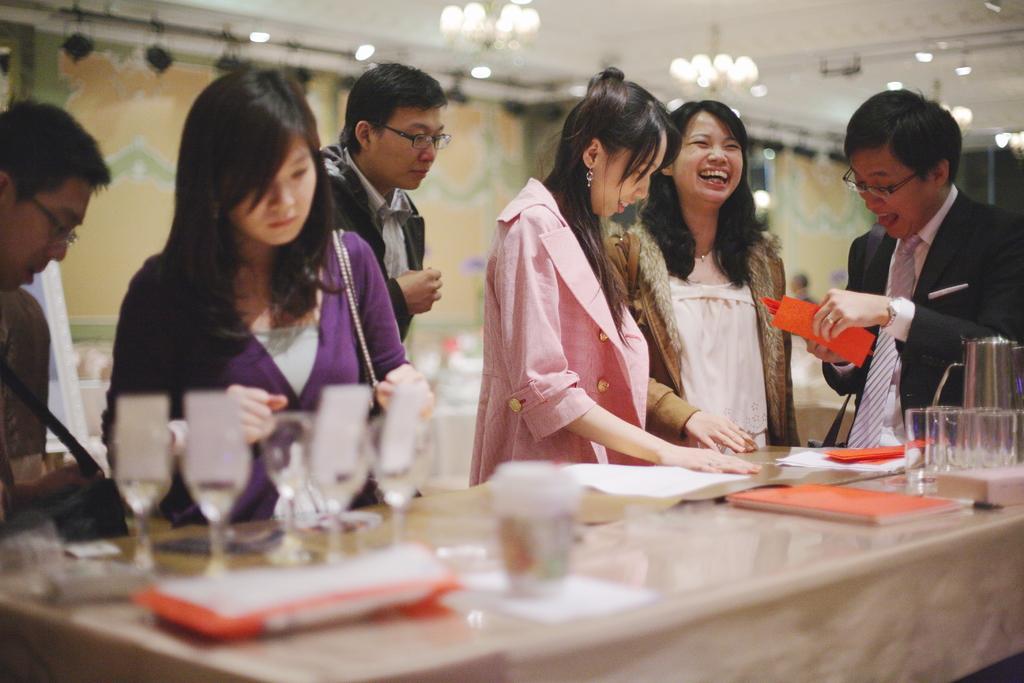In one or two sentences, can you explain what this image depicts? In this picture there are people in the center of the image and there is a desk in front of them, on which there are books and glasses, there are lamps on the roof at the top side of the image and there are painted walls in the background area of the image. 